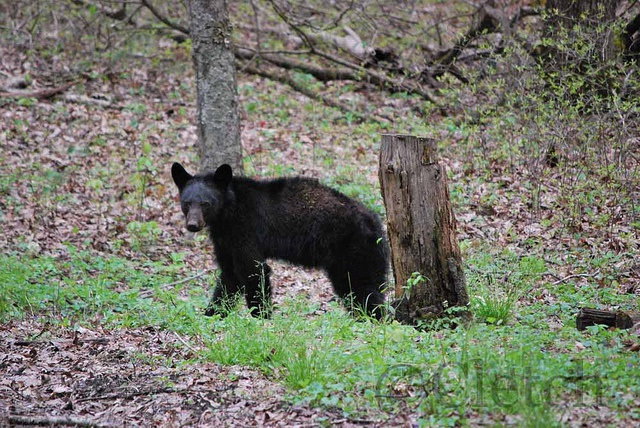Describe the objects in this image and their specific colors. I can see a bear in gray, black, darkgray, and green tones in this image. 